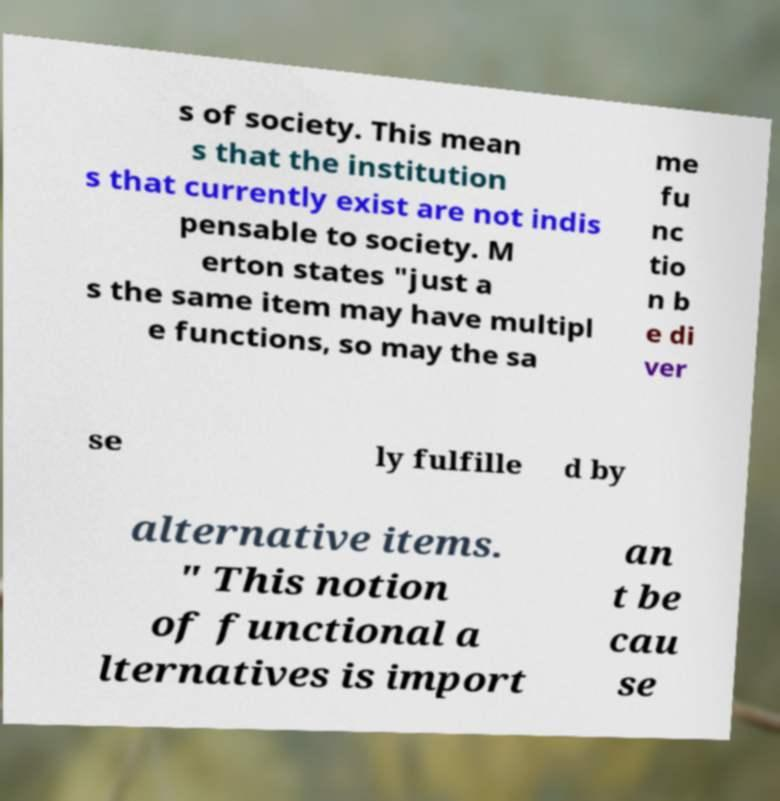There's text embedded in this image that I need extracted. Can you transcribe it verbatim? s of society. This mean s that the institution s that currently exist are not indis pensable to society. M erton states "just a s the same item may have multipl e functions, so may the sa me fu nc tio n b e di ver se ly fulfille d by alternative items. " This notion of functional a lternatives is import an t be cau se 